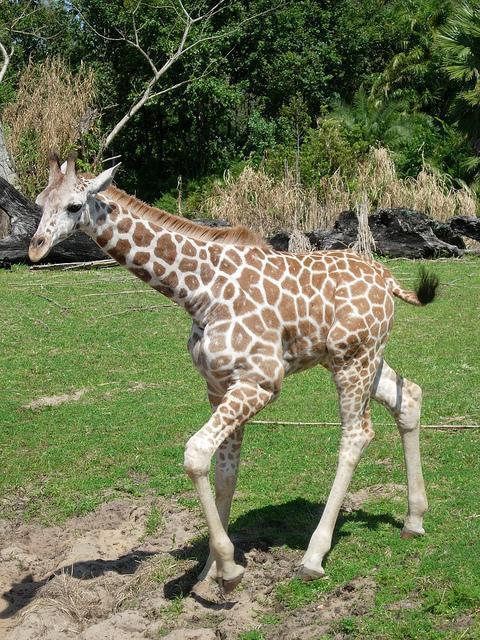How many legs does the giraffe have?
Give a very brief answer. 4. How many people are in the picture?
Give a very brief answer. 0. 